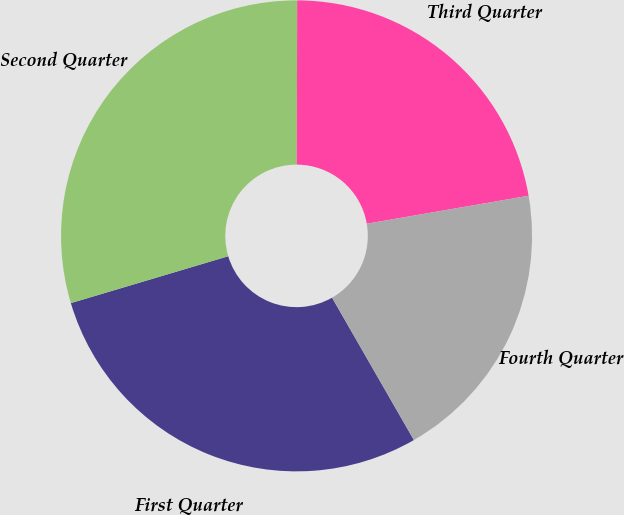<chart> <loc_0><loc_0><loc_500><loc_500><pie_chart><fcel>First Quarter<fcel>Second Quarter<fcel>Third Quarter<fcel>Fourth Quarter<nl><fcel>28.69%<fcel>29.65%<fcel>22.23%<fcel>19.42%<nl></chart> 